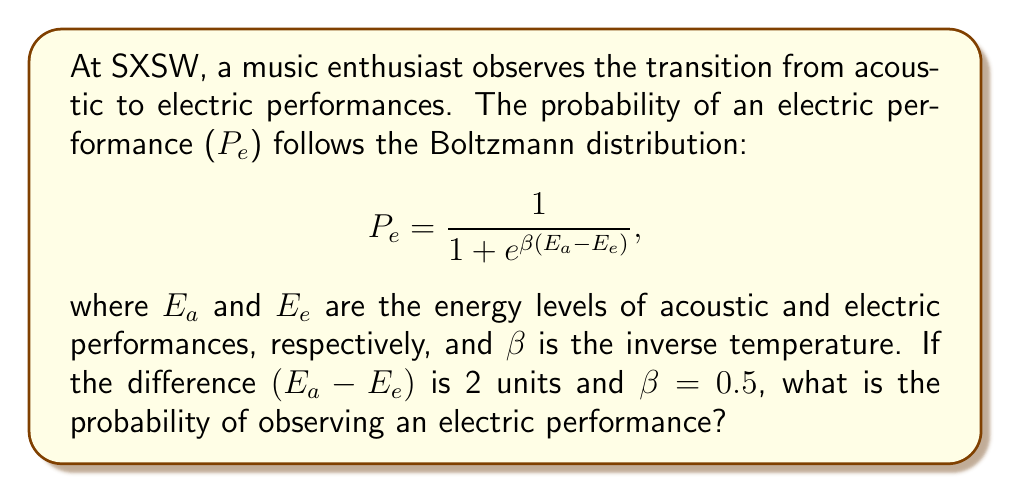Can you answer this question? Let's approach this step-by-step:

1) We are given the Boltzmann distribution for the probability of an electric performance:

   $$P_e = \frac{1}{1 + e^{\beta(E_a - E_e)}}$$

2) We are also given:
   - $(E_a - E_e) = 2$ units
   - $\beta = 0.5$

3) Let's substitute these values into our equation:

   $$P_e = \frac{1}{1 + e^{0.5(2)}}$$

4) Simplify the exponent:

   $$P_e = \frac{1}{1 + e^1}$$

5) Calculate $e^1$:

   $$P_e = \frac{1}{1 + 2.71828...}$$

6) Add the denominator:

   $$P_e = \frac{1}{3.71828...}$$

7) Calculate the final probability:

   $$P_e \approx 0.2689$$

Thus, the probability of observing an electric performance is approximately 0.2689 or about 26.89%.
Answer: $0.2689$ 